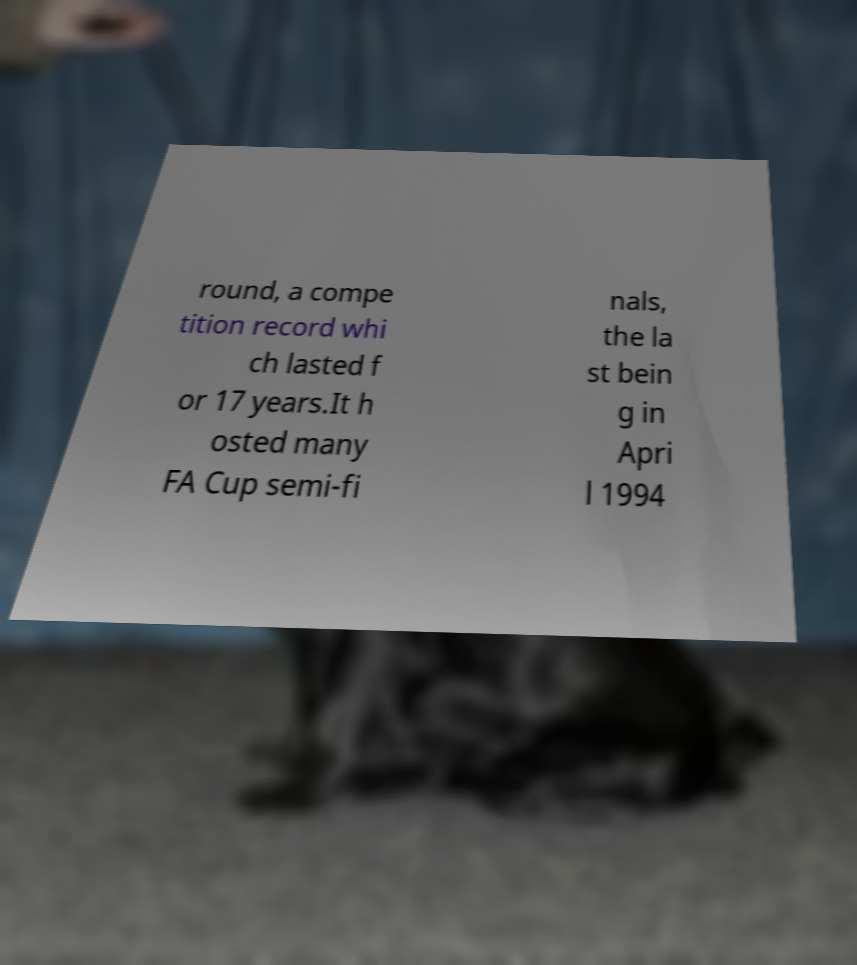Can you accurately transcribe the text from the provided image for me? round, a compe tition record whi ch lasted f or 17 years.It h osted many FA Cup semi-fi nals, the la st bein g in Apri l 1994 